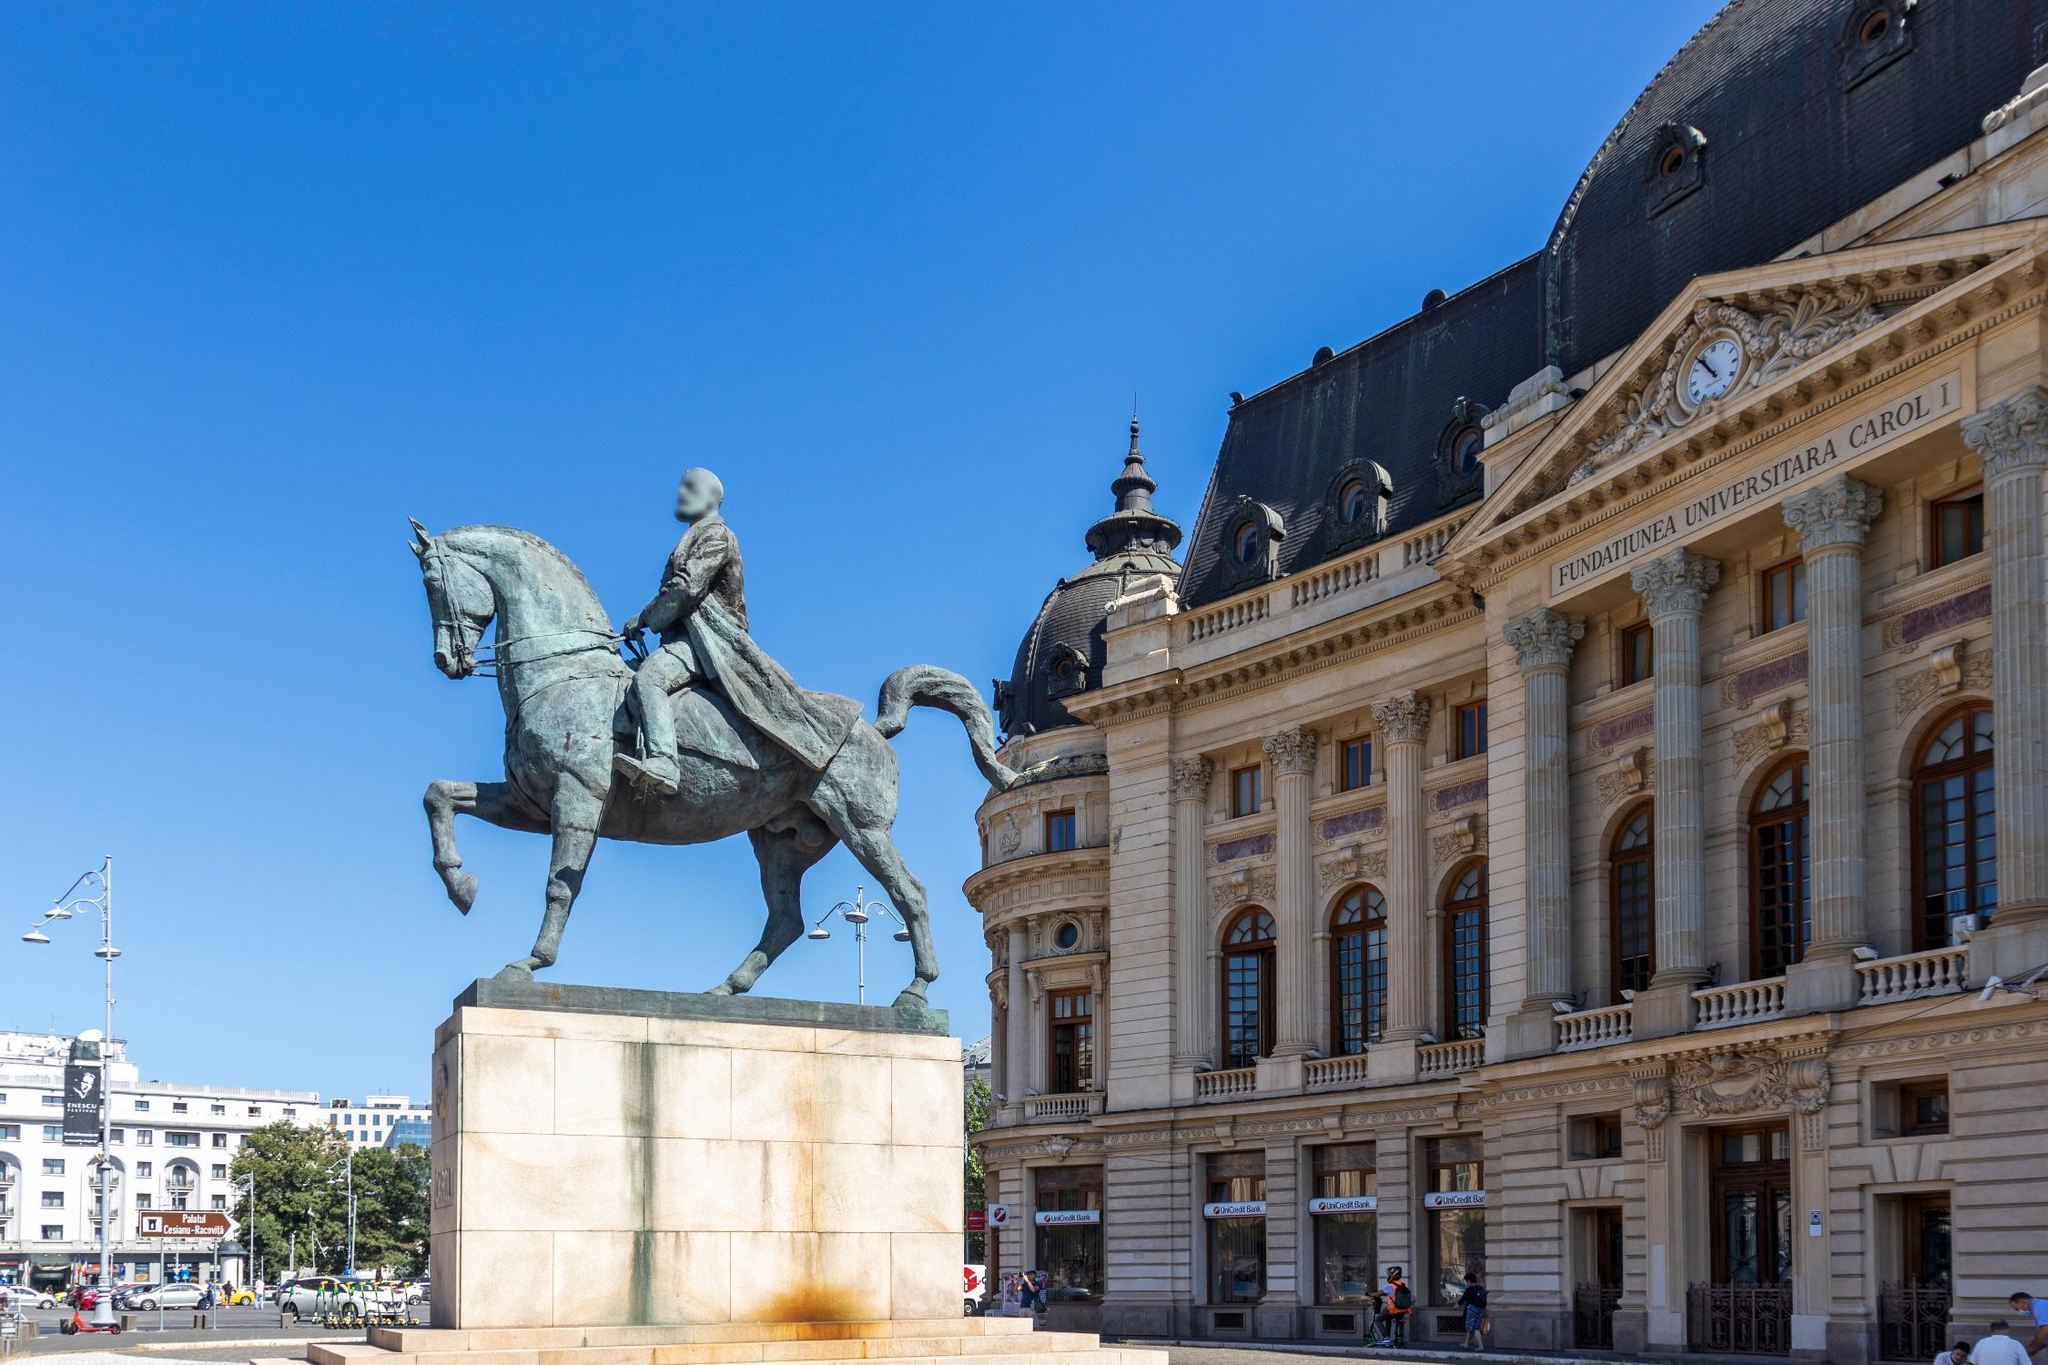What can you tell me about the history behind this statue? This statue represents a historical figure who played a significant role in the country's history. Depicting a moment of triumph, the figure on the horse symbolizes leadership, bravery, and victory. Such statues are typically erected to commemorate notable leaders, battles, or significant historical events. They serve as reminders of the past and inspire future generations with tales of courage and accomplishment. The architectural grandeur of the building behind further suggests that this statue stands in an area of historical and cultural importance. Can you elaborate on the architectural style of the building in the background? The building in the background displays neoclassical architecture, characterized by its grandeur, symmetry, and use of classical Greek and Roman elements. Distinctive features include the tall columns, triangular pediment, and elaborate cornices. The building's facade exhibits intricate detailing, with ornamental carvings and decorative elements that emphasize its majestic appearance. The dome on the right side of the building is another key feature, adding to the overall historical and architectural significance of the structure. Such buildings are often associated with important public institutions, cultural centers, or historical landmarks. Imagine the statue and the building come to life – what might their story be? As the moonlight casts a silvery glow upon the plaza, a magical transformation begins. The statue of the valiant leader and his horse breathes life, and they descend from their pedestal. The leader, sword still raised, embarks on a nocturnal exploration of the city, the horse's hooves echoing softly against the cobblestones. The once motionless figures traverse through time, witnessing the growth and changes of the city they once protected.

The building, with its grand facade and dome, awakens to become a beaming guardian of history. Its doors open wide, and light pours out, revealing hidden corridors and rooms filled with ancient artifacts and chronicles of the past. It stands proud, sharing tales of the people and events that shaped the nation.

Together, the animated statue and the sentient building weave a mesmerizing narrative of valor, resilience, and eternal guardianship. They are the silent witnesses of history, now temporarily freed to reminisce and protect the legacies they embody, ensuring that the stories of old remain alive and revered for generations to come. 